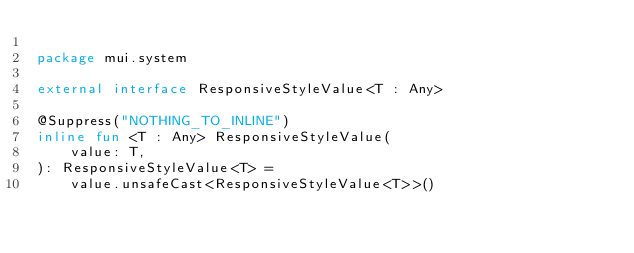Convert code to text. <code><loc_0><loc_0><loc_500><loc_500><_Kotlin_>
package mui.system

external interface ResponsiveStyleValue<T : Any>

@Suppress("NOTHING_TO_INLINE")
inline fun <T : Any> ResponsiveStyleValue(
    value: T,
): ResponsiveStyleValue<T> =
    value.unsafeCast<ResponsiveStyleValue<T>>()
</code> 